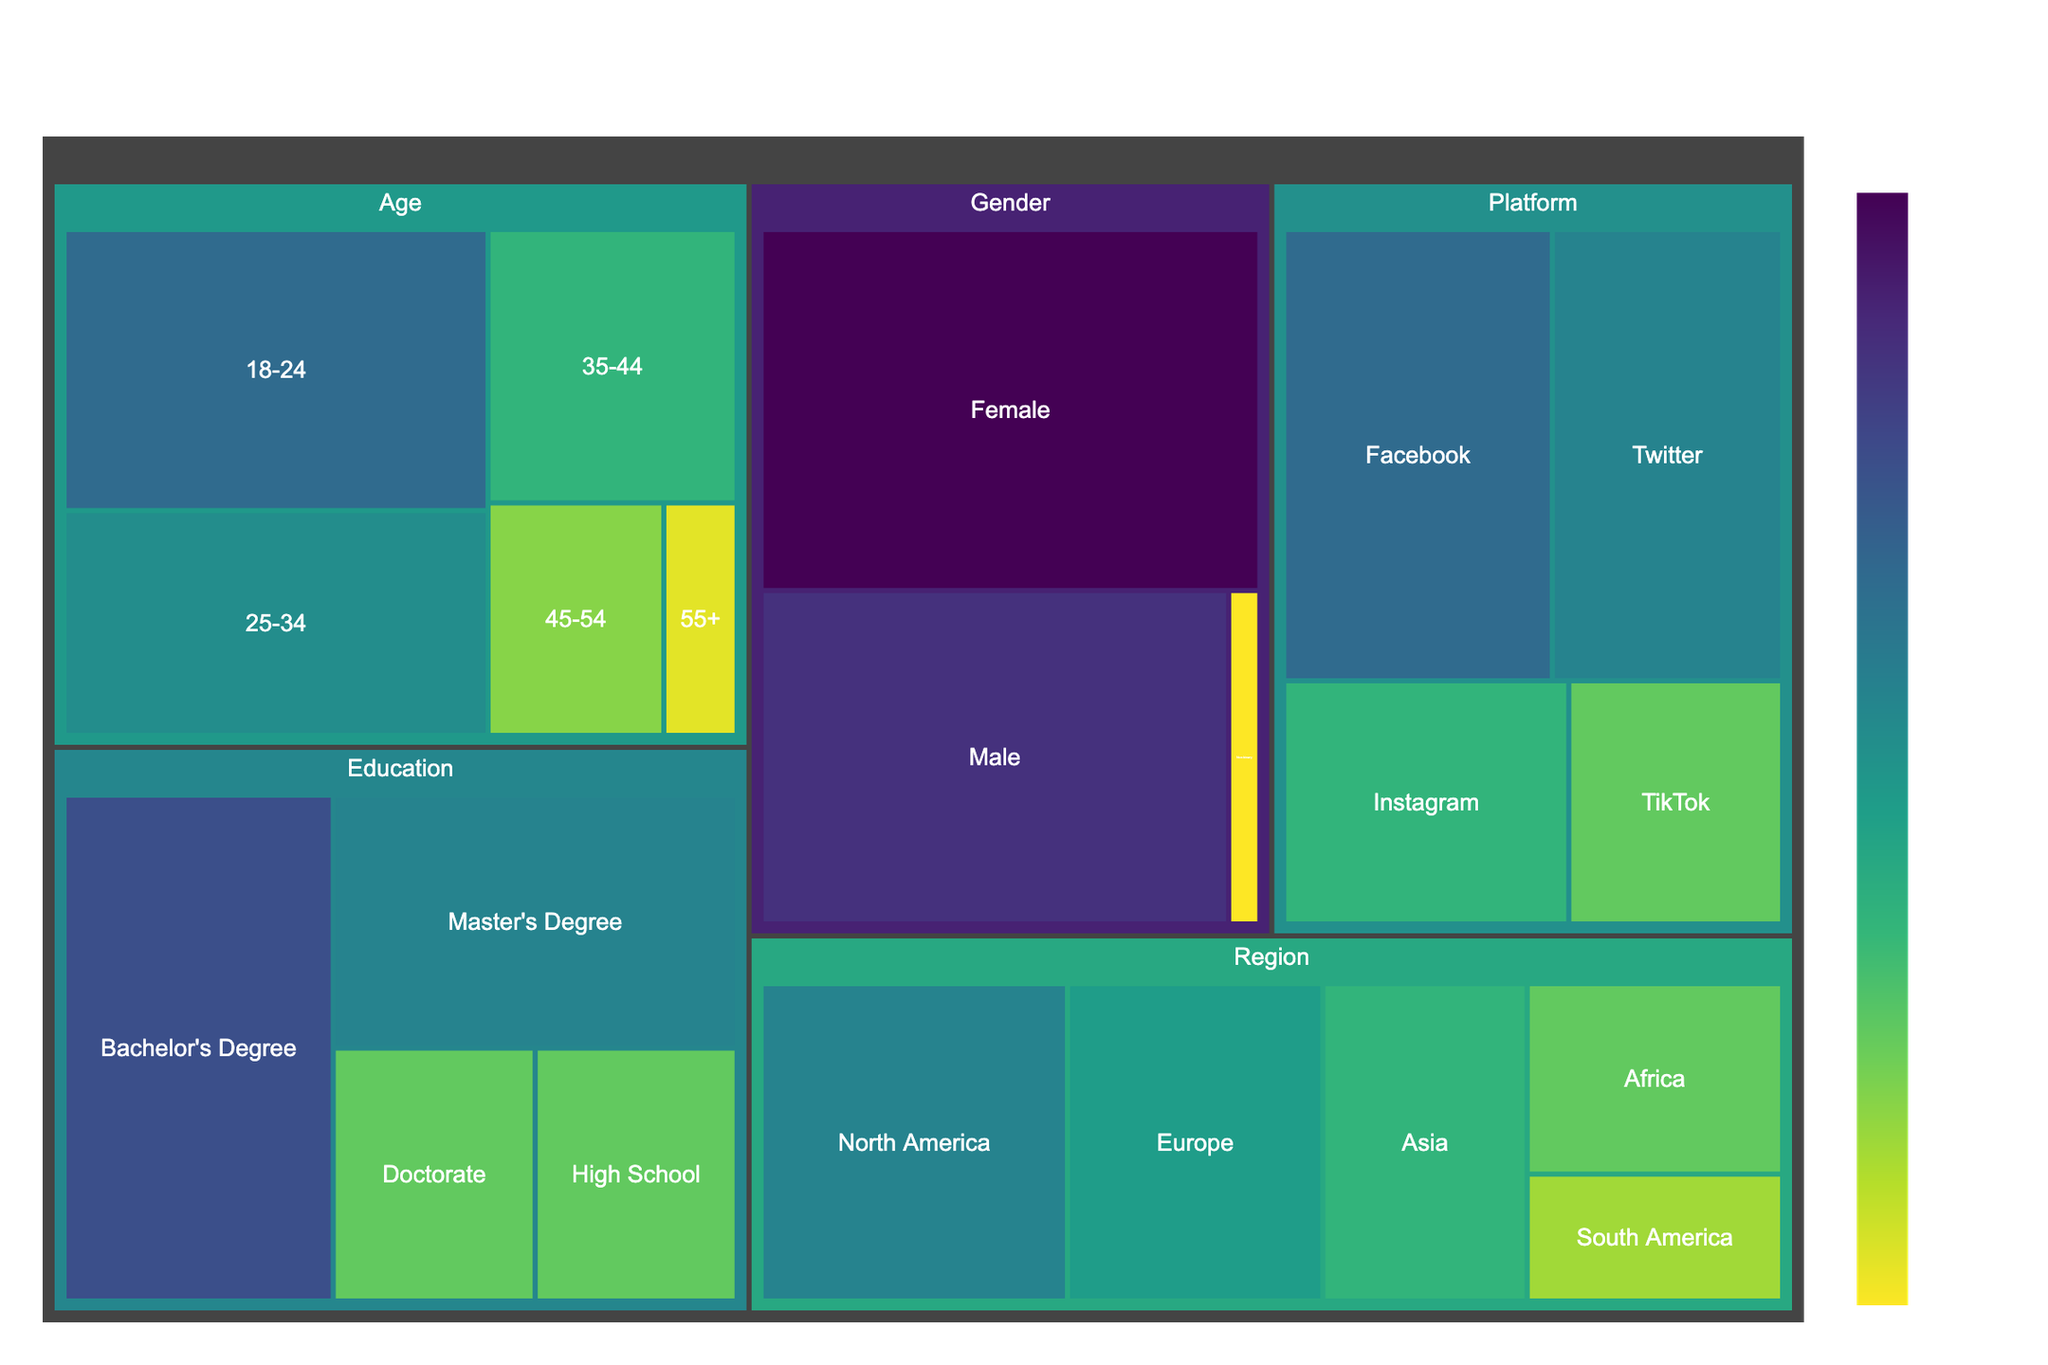What is the highest engagement value by demographic factors? The highest engagement value can be identified by looking at the box with the largest size and highest number in the treemap. The largest value in the figure under 'Gender' category is 'Female' with a value of 52.
Answer: Female, 52 Which age group has the least engagement in online activism campaigns? To find the age group with the least engagement, observe the subset under 'Age.' The smallest box under 'Age' is '55+' with an engagement value of 5.
Answer: 55+, 5 What is the total engagement value for the 'Education' category? Sum the values of all subcategories under 'Education.' These are 15 (High School) + 40 (Bachelor's) + 30 (Master's) + 15 (Doctorate), giving a total of 100.
Answer: 100 How does user engagement in North America compare to Europe in online activism campaigns? Find the values for 'North America' and 'Europe' under 'Region.' North America has 30 and Europe has 25. The comparison shows that North America has higher engagement.
Answer: North America, 30 vs Europe, 25 Which platform shows the highest engagement in online activism campaigns? Look at the subcategories under 'Platform' to find the one with the highest value. The highest engagement is on Facebook with a value of 35.
Answer: Facebook, 35 What is the combined engagement value for Male and Non-binary in the 'Gender' category? Sum the values for 'Male' and 'Non-binary' under 'Gender.' These are 45 (Male) + 3 (Non-binary), giving a combined value of 48.
Answer: 48 What percentage of the total engagement does the '35-44' age group represent? First, sum the values under 'Age' to get the total engagement. This is 35 (18-24) + 28 (25-34) + 20 (35-44) + 12 (45-54) + 5 (55+), which equals 100. Then, calculate the percentage for the '35-44' group: (20/100) * 100% = 20%.
Answer: 20% How does engagement in Asia compare to engagement in South America? Compare the values for 'Asia' and 'South America' under 'Region.' Asia has an engagement value of 20, whereas South America has 10. Asia's engagement is double that of South America.
Answer: Asia, 20 vs South America, 10 Which subcategory under 'Education' has the second highest engagement value? Identify the ranking of values under 'Education.' The highest is 'Bachelor's Degree' with 40, and the second highest is 'Master's Degree' with 30.
Answer: Master's Degree, 30 